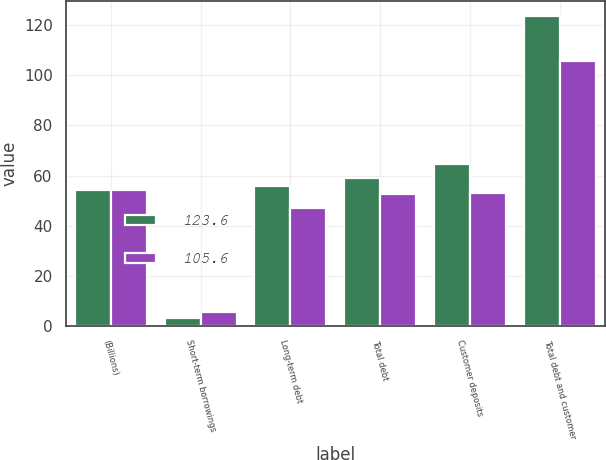Convert chart to OTSL. <chart><loc_0><loc_0><loc_500><loc_500><stacked_bar_chart><ecel><fcel>(Billions)<fcel>Short-term borrowings<fcel>Long-term debt<fcel>Total debt<fcel>Customer deposits<fcel>Total debt and customer<nl><fcel>123.6<fcel>54.4<fcel>3.3<fcel>55.8<fcel>59.1<fcel>64.5<fcel>123.6<nl><fcel>105.6<fcel>54.4<fcel>5.6<fcel>47<fcel>52.6<fcel>53<fcel>105.6<nl></chart> 